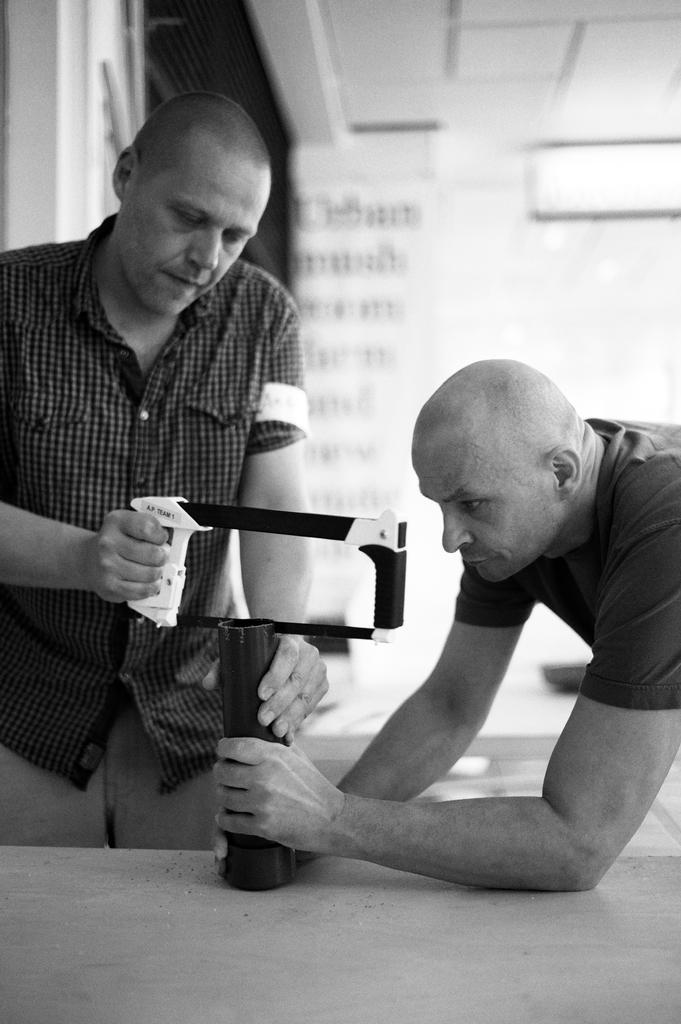Can you describe this image briefly? In this black and white image, we can see two persons wearing clothes. There is a person on the left side of the image holding a pipe and saw with his hands. 